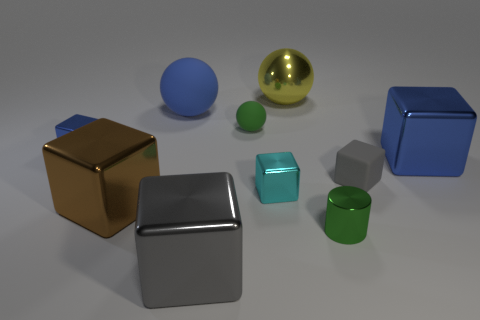Subtract all cyan cubes. How many cubes are left? 5 Subtract all small gray matte cubes. How many cubes are left? 5 Subtract all red blocks. Subtract all purple cylinders. How many blocks are left? 6 Subtract all cylinders. How many objects are left? 9 Subtract all brown metal blocks. Subtract all big yellow blocks. How many objects are left? 9 Add 4 tiny gray matte cubes. How many tiny gray matte cubes are left? 5 Add 7 brown cylinders. How many brown cylinders exist? 7 Subtract 0 cyan cylinders. How many objects are left? 10 